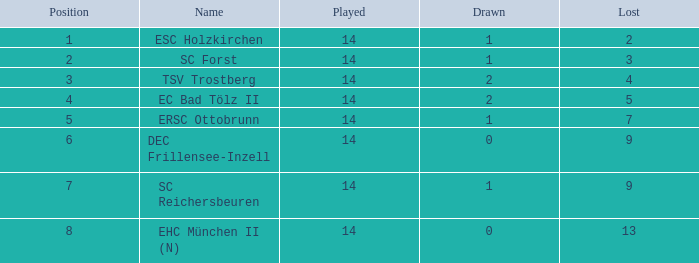Which Lost is the lowest one that has a Name of esc holzkirchen, and Played smaller than 14? None. 